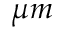<formula> <loc_0><loc_0><loc_500><loc_500>\mu m</formula> 